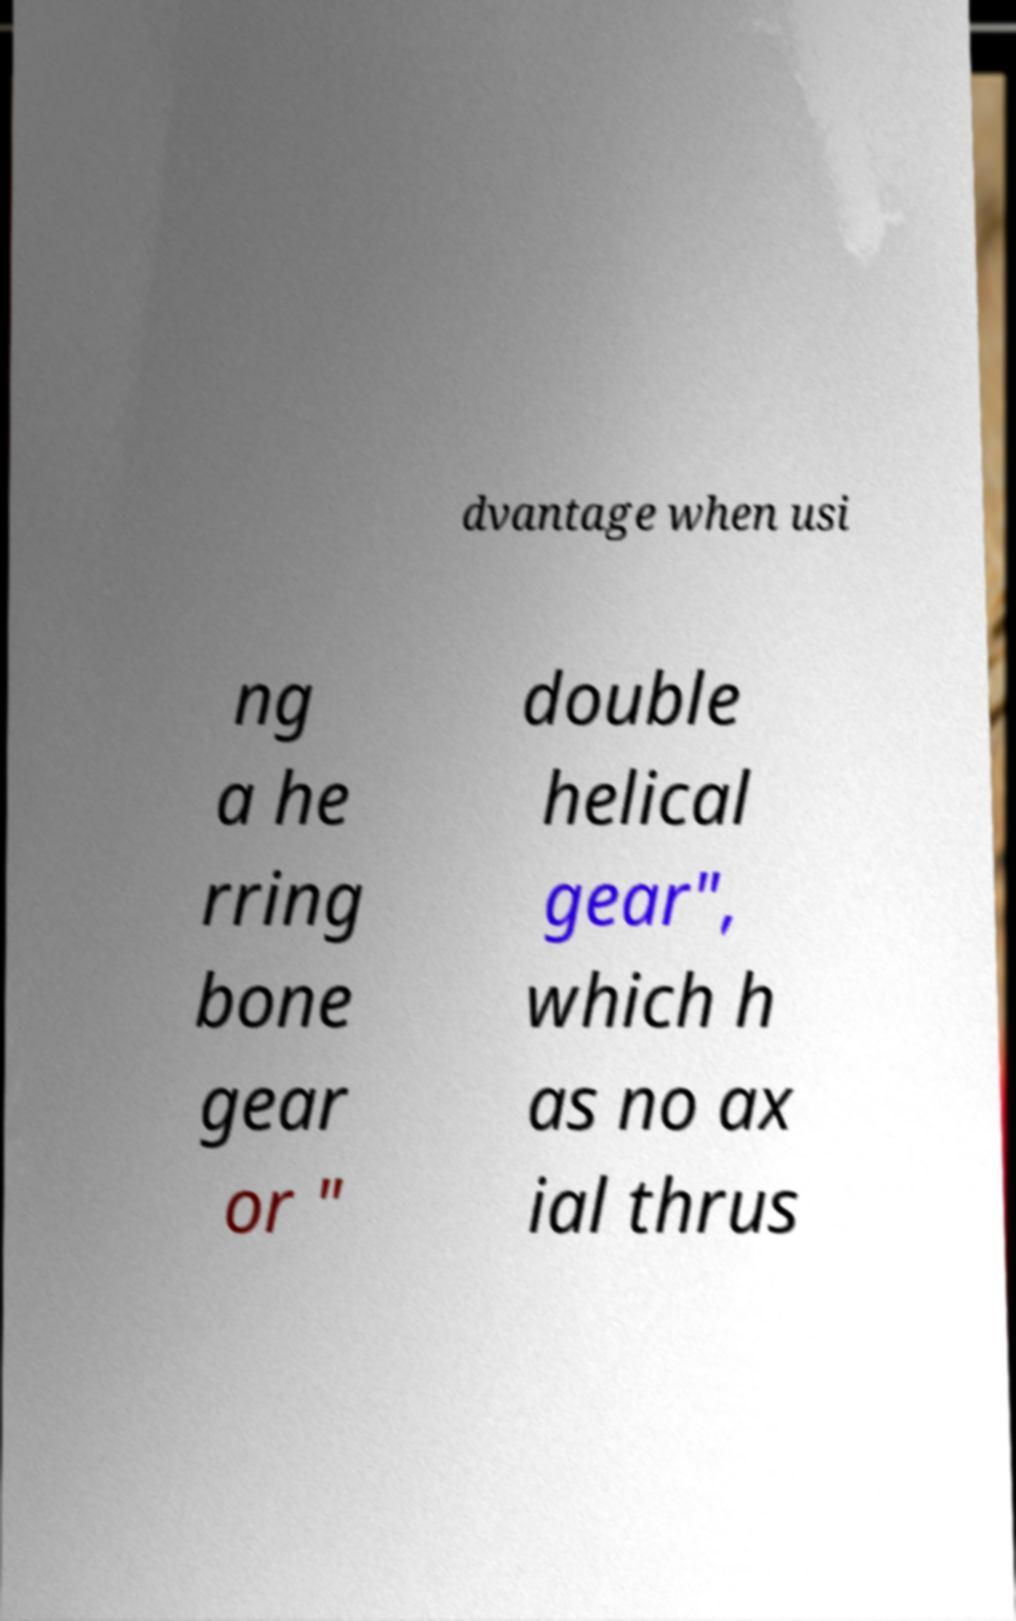Could you assist in decoding the text presented in this image and type it out clearly? dvantage when usi ng a he rring bone gear or " double helical gear", which h as no ax ial thrus 